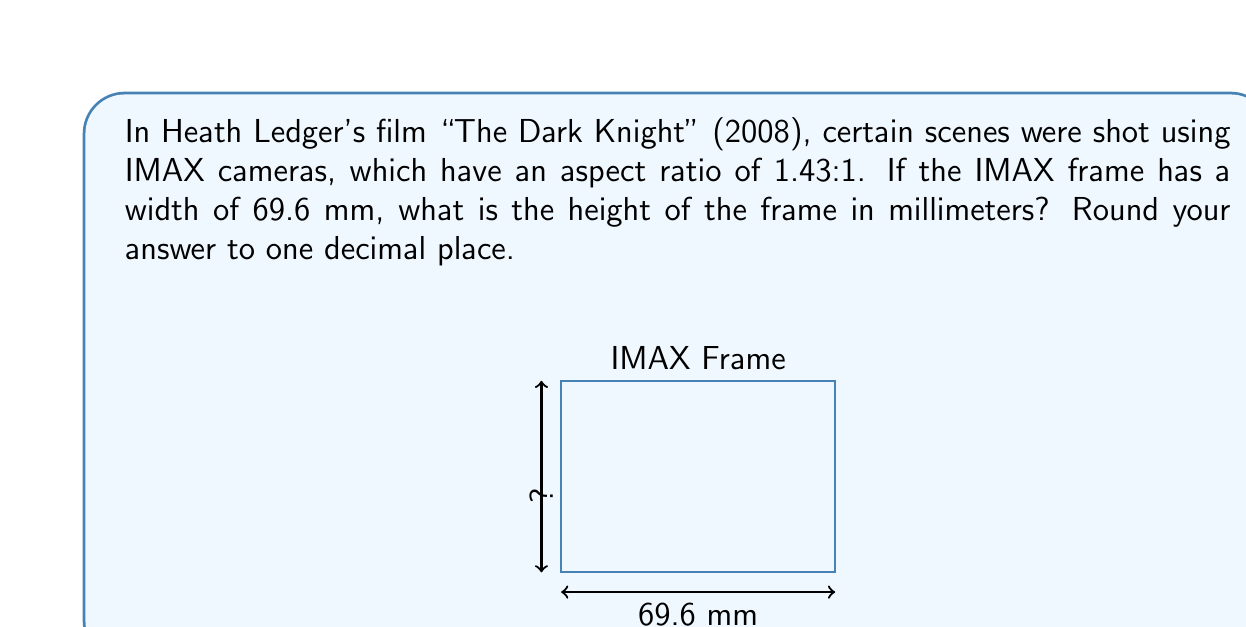Give your solution to this math problem. To solve this problem, we'll use the aspect ratio formula and the given information:

1) The aspect ratio is given as 1.43:1, which means the ratio of width to height.

2) We can express this as an equation:
   $\frac{\text{width}}{\text{height}} = 1.43$

3) We know the width is 69.6 mm, so let's substitute this:
   $\frac{69.6}{\text{height}} = 1.43$

4) To solve for height, we multiply both sides by height:
   $69.6 = 1.43 \times \text{height}$

5) Now divide both sides by 1.43:
   $\frac{69.6}{1.43} = \text{height}$

6) Calculate:
   $\text{height} = 48.67132867132867...$

7) Rounding to one decimal place:
   $\text{height} \approx 48.7$ mm

Therefore, the height of the IMAX frame used in "The Dark Knight" is approximately 48.7 mm.
Answer: 48.7 mm 